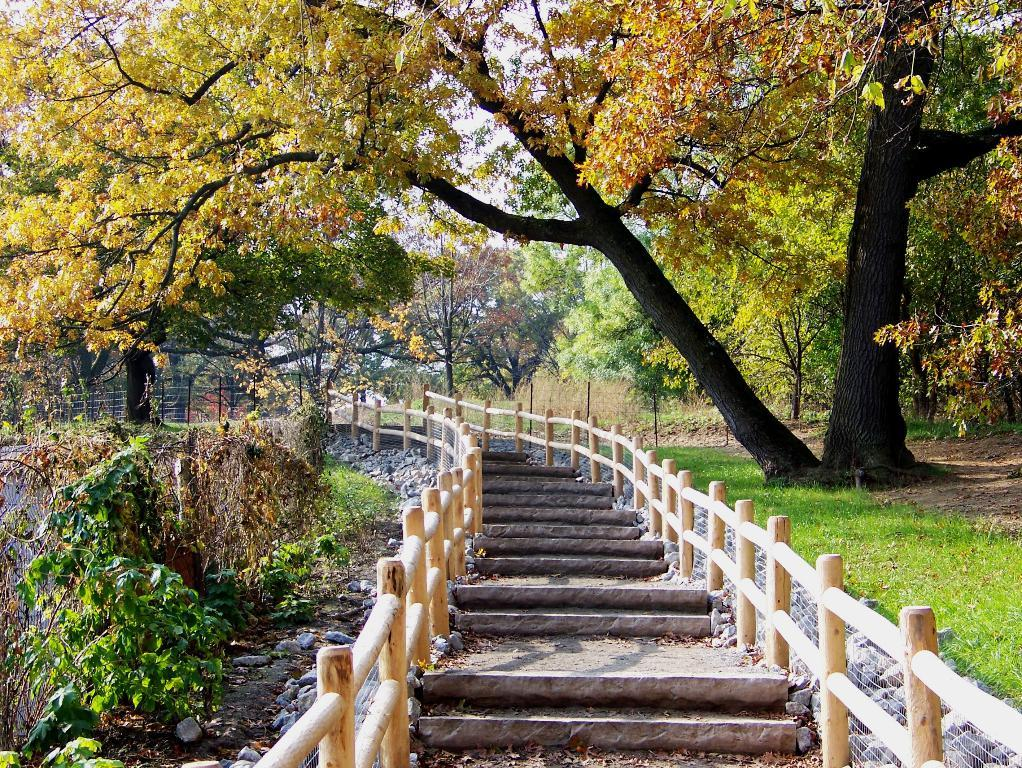What type of structure is present in the image? There are stairs and a fence in the image. What type of material can be seen in the image? There are stones and a mesh in the image. What type of vegetation is present in the image? There are plants, grass, and trees in the image. What type of dinner is being served on the brick in the image? There is no dinner or brick present in the image. What is the mass of the plants in the image? The mass of the plants cannot be determined from the image alone, as it does not provide any information about their size or weight. 